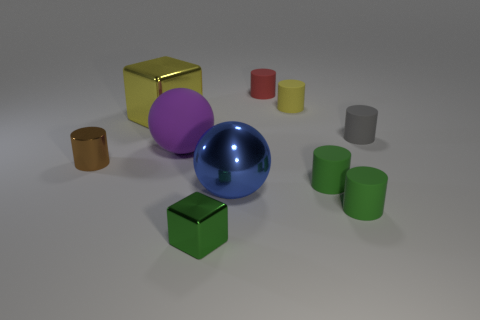The large thing that is on the right side of the sphere that is behind the blue shiny sphere is made of what material?
Provide a succinct answer. Metal. What number of objects are either large gray matte objects or small matte cylinders in front of the yellow matte thing?
Keep it short and to the point. 3. The blue sphere that is the same material as the large cube is what size?
Give a very brief answer. Large. How many yellow objects are either metal blocks or cylinders?
Your answer should be very brief. 2. There is a small rubber object that is the same color as the large cube; what is its shape?
Your answer should be very brief. Cylinder. Is there anything else that has the same material as the big blue ball?
Make the answer very short. Yes. Do the big metal thing in front of the small gray cylinder and the tiny metallic thing left of the small green metal cube have the same shape?
Provide a succinct answer. No. How many cylinders are there?
Give a very brief answer. 6. What is the shape of the tiny gray thing that is the same material as the tiny yellow cylinder?
Provide a succinct answer. Cylinder. Are there any other things that have the same color as the metallic cylinder?
Your response must be concise. No. 